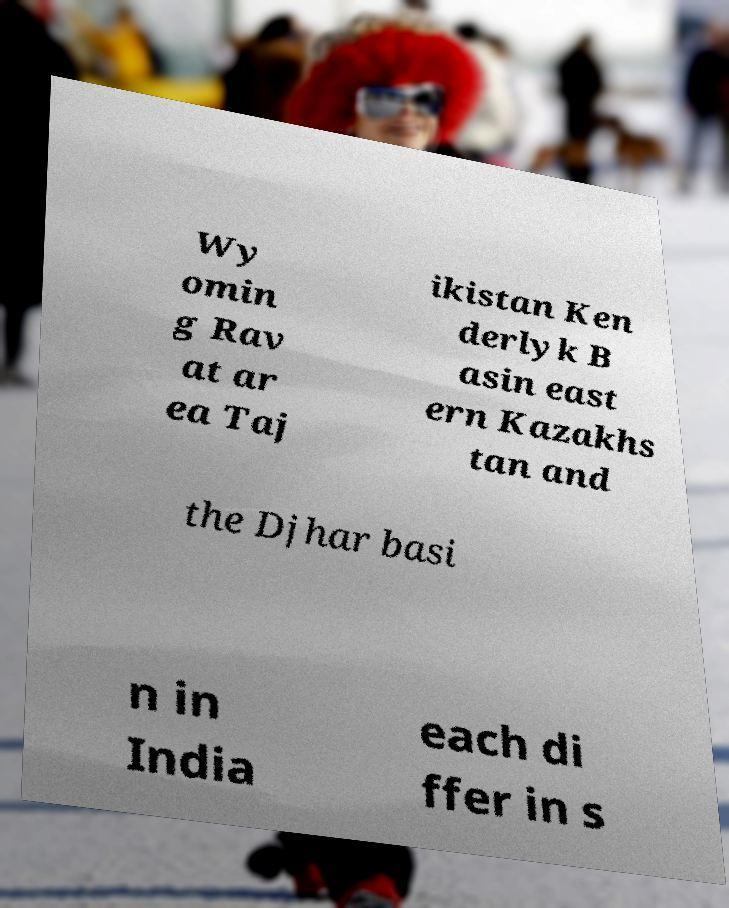Could you extract and type out the text from this image? Wy omin g Rav at ar ea Taj ikistan Ken derlyk B asin east ern Kazakhs tan and the Djhar basi n in India each di ffer in s 